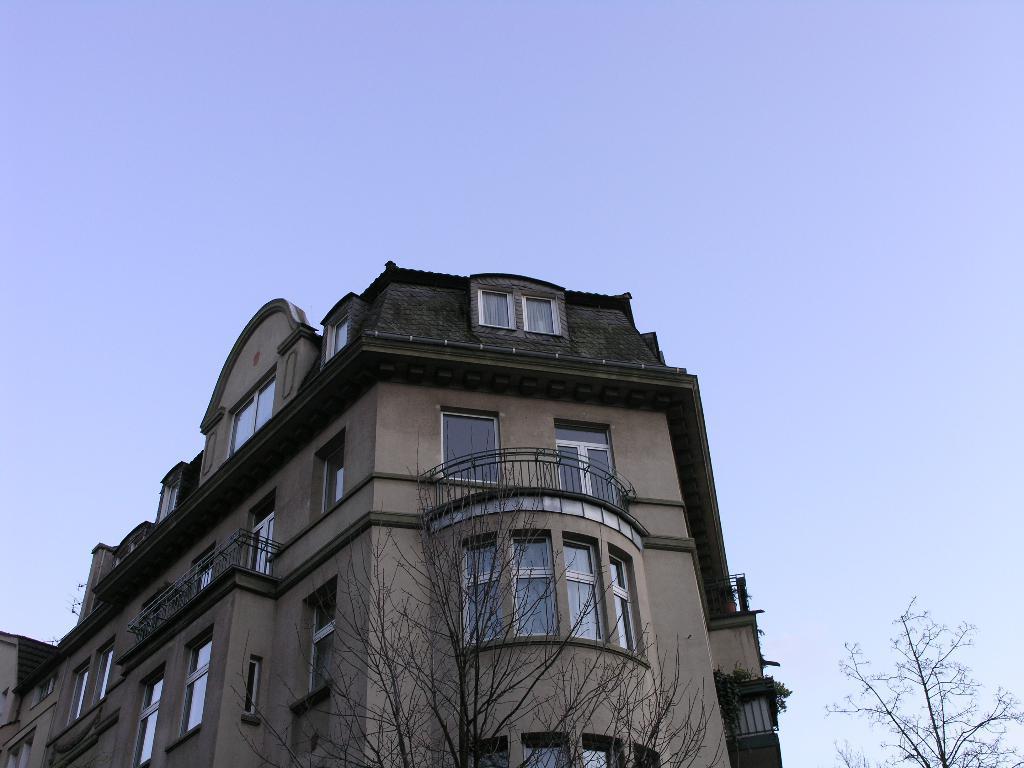Describe this image in one or two sentences. There are dry trees and a building at the bottom of this image, and there is a blue sky in the background. 